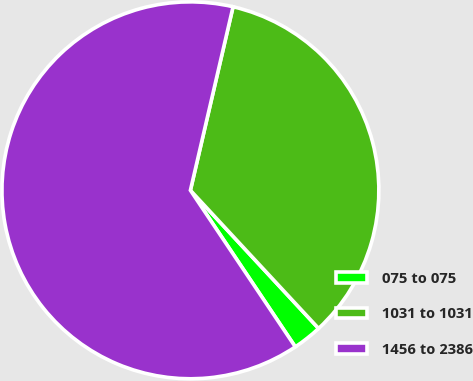Convert chart. <chart><loc_0><loc_0><loc_500><loc_500><pie_chart><fcel>075 to 075<fcel>1031 to 1031<fcel>1456 to 2386<nl><fcel>2.51%<fcel>34.46%<fcel>63.03%<nl></chart> 